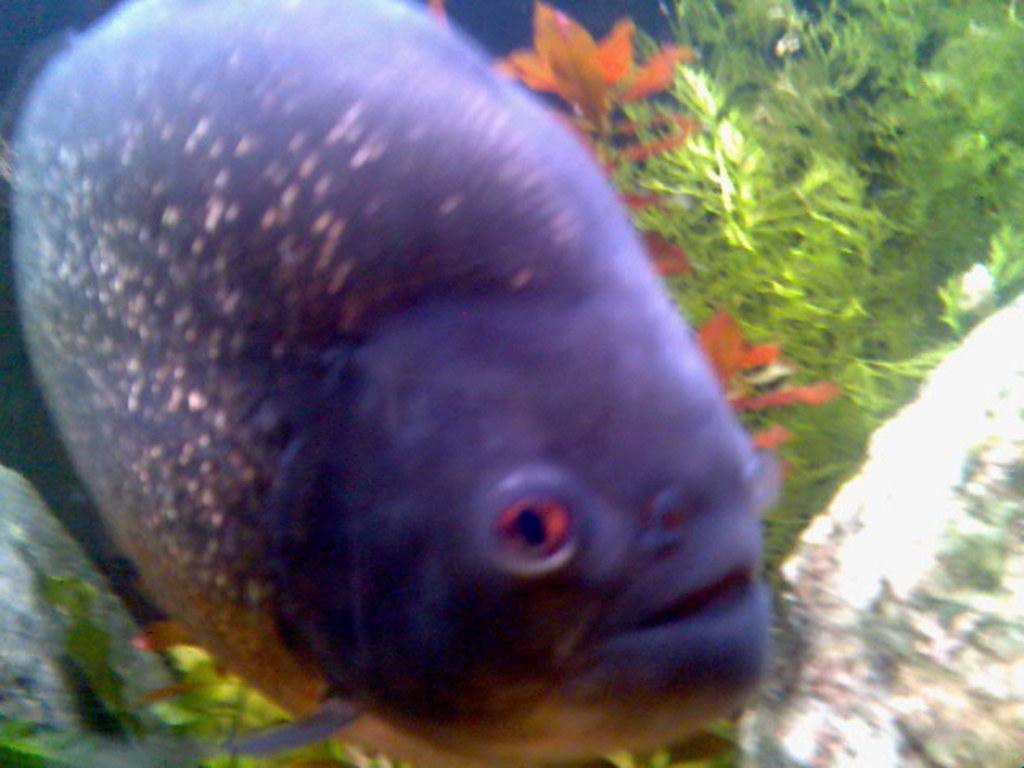What type of animal is in the image? There is a fish in the image. What color is the fish? The fish is purple in color. What else can be seen in the water with the fish? There are plants and rocks in the water. How many coaches are visible in the image? There are no coaches present in the image. What type of stove is being used to cook the fish in the image? There is no stove present in the image, and the fish is not being cooked. 